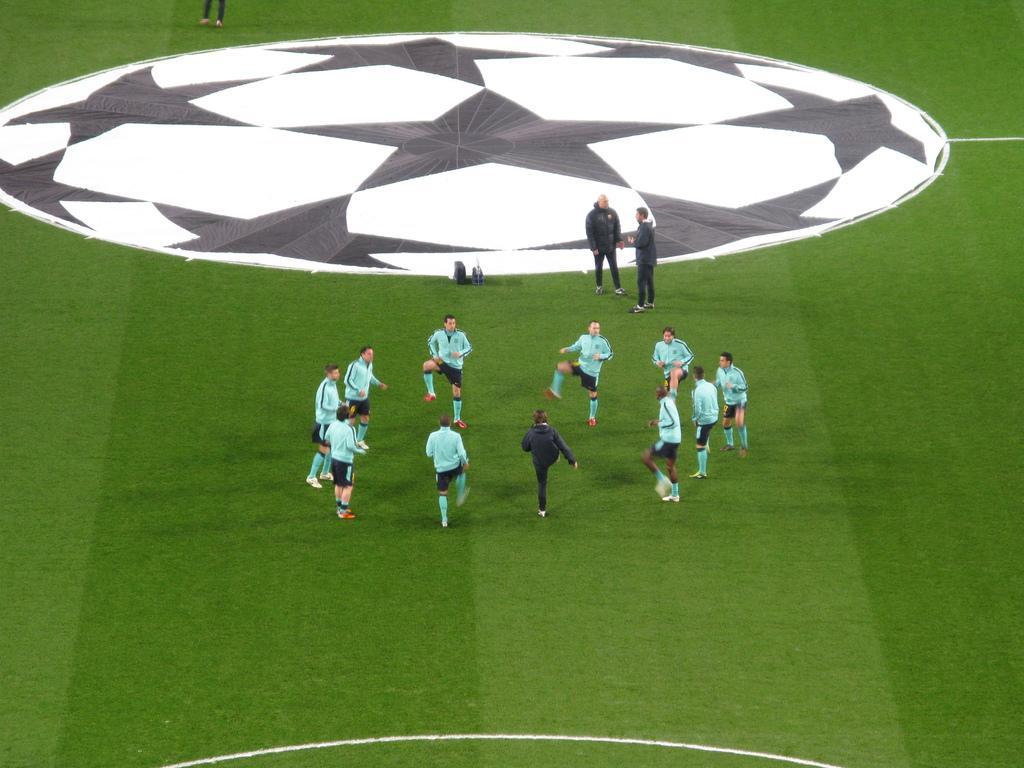In one or two sentences, can you explain what this image depicts? In this image, there are few people standing. It might be a cloth, which is black and white in color. I think this is a ground. At the top of the image, I can see a person's legs. 